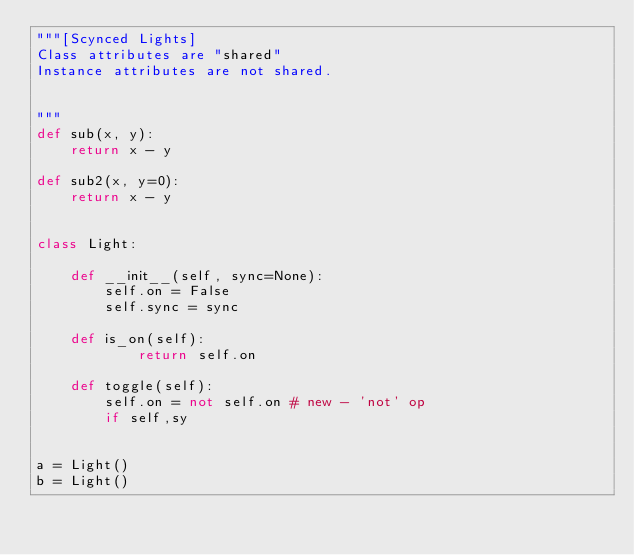Convert code to text. <code><loc_0><loc_0><loc_500><loc_500><_Python_>"""[Scynced Lights]
Class attributes are "shared"
Instance attributes are not shared.


"""
def sub(x, y):
    return x - y

def sub2(x, y=0):
    return x - y


class Light:

    def __init__(self, sync=None):
        self.on = False
        self.sync = sync

    def is_on(self):
            return self.on

    def toggle(self):
        self.on = not self.on # new - 'not' op
        if self,sy


a = Light()
b = Light()
</code> 